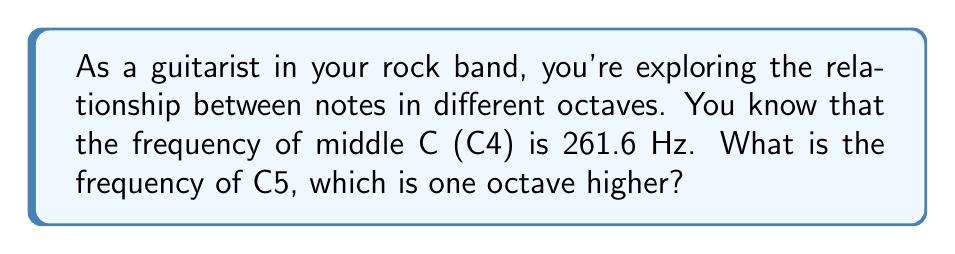Can you solve this math problem? To solve this problem, we need to understand the relationship between frequencies of musical notes in different octaves. Here's a step-by-step explanation:

1. In the Western musical scale, each octave represents a doubling of frequency.

2. The relationship between frequency and octaves can be expressed mathematically as:

   $f_n = f_0 \cdot 2^n$

   Where:
   $f_n$ is the frequency of the note in the new octave
   $f_0$ is the frequency of the reference note
   $n$ is the number of octaves away from the reference note (positive for higher, negative for lower)

3. In this case:
   $f_0 = 261.6$ Hz (the frequency of C4)
   $n = 1$ (C5 is one octave higher than C4)

4. Plugging these values into our equation:

   $f_1 = 261.6 \cdot 2^1$

5. Simplify:
   $f_1 = 261.6 \cdot 2 = 523.2$ Hz

Therefore, the frequency of C5 is 523.2 Hz.
Answer: 523.2 Hz 